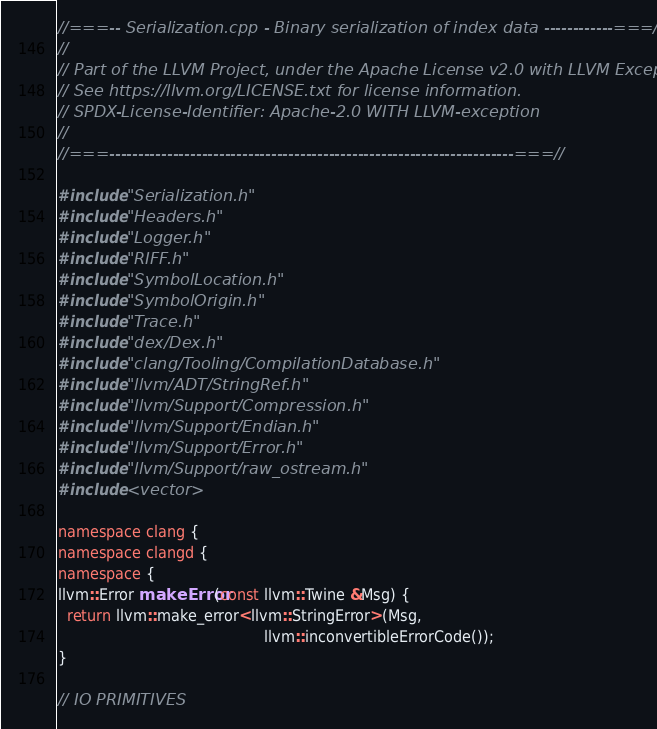<code> <loc_0><loc_0><loc_500><loc_500><_C++_>//===-- Serialization.cpp - Binary serialization of index data ------------===//
//
// Part of the LLVM Project, under the Apache License v2.0 with LLVM Exceptions.
// See https://llvm.org/LICENSE.txt for license information.
// SPDX-License-Identifier: Apache-2.0 WITH LLVM-exception
//
//===----------------------------------------------------------------------===//

#include "Serialization.h"
#include "Headers.h"
#include "Logger.h"
#include "RIFF.h"
#include "SymbolLocation.h"
#include "SymbolOrigin.h"
#include "Trace.h"
#include "dex/Dex.h"
#include "clang/Tooling/CompilationDatabase.h"
#include "llvm/ADT/StringRef.h"
#include "llvm/Support/Compression.h"
#include "llvm/Support/Endian.h"
#include "llvm/Support/Error.h"
#include "llvm/Support/raw_ostream.h"
#include <vector>

namespace clang {
namespace clangd {
namespace {
llvm::Error makeError(const llvm::Twine &Msg) {
  return llvm::make_error<llvm::StringError>(Msg,
                                             llvm::inconvertibleErrorCode());
}

// IO PRIMITIVES</code> 